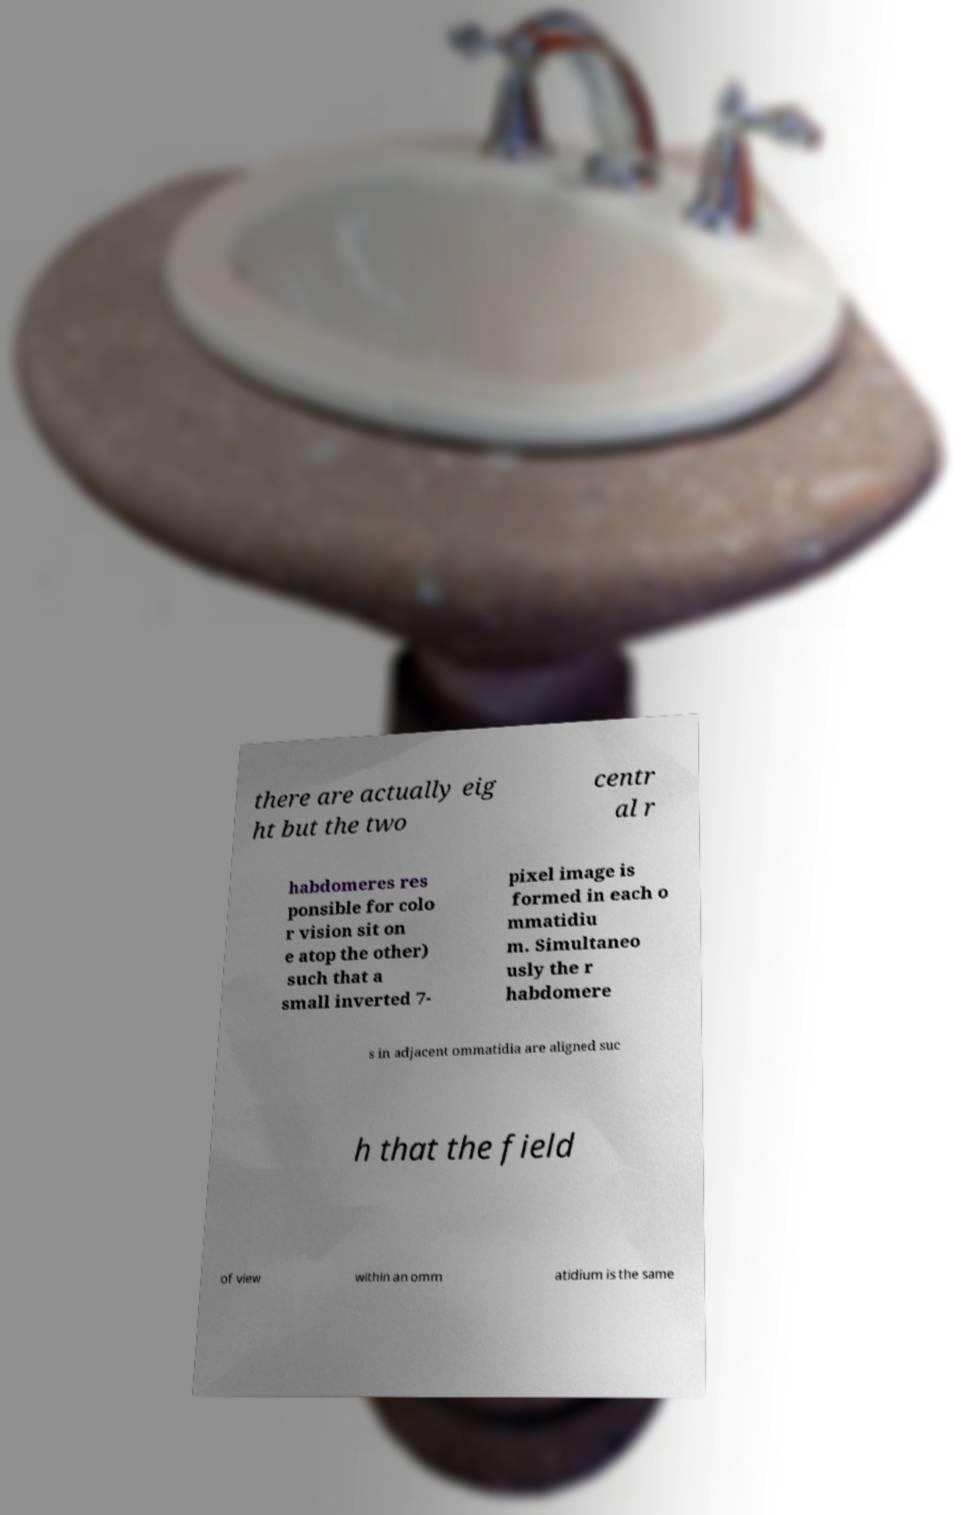There's text embedded in this image that I need extracted. Can you transcribe it verbatim? there are actually eig ht but the two centr al r habdomeres res ponsible for colo r vision sit on e atop the other) such that a small inverted 7- pixel image is formed in each o mmatidiu m. Simultaneo usly the r habdomere s in adjacent ommatidia are aligned suc h that the field of view within an omm atidium is the same 